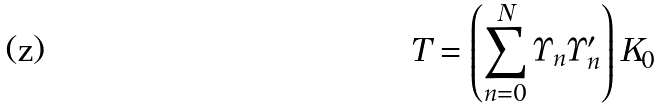Convert formula to latex. <formula><loc_0><loc_0><loc_500><loc_500>T = \left ( \sum _ { n = 0 } ^ { N } \Upsilon _ { n } \Upsilon ^ { \prime } _ { n } \right ) K _ { 0 }</formula> 